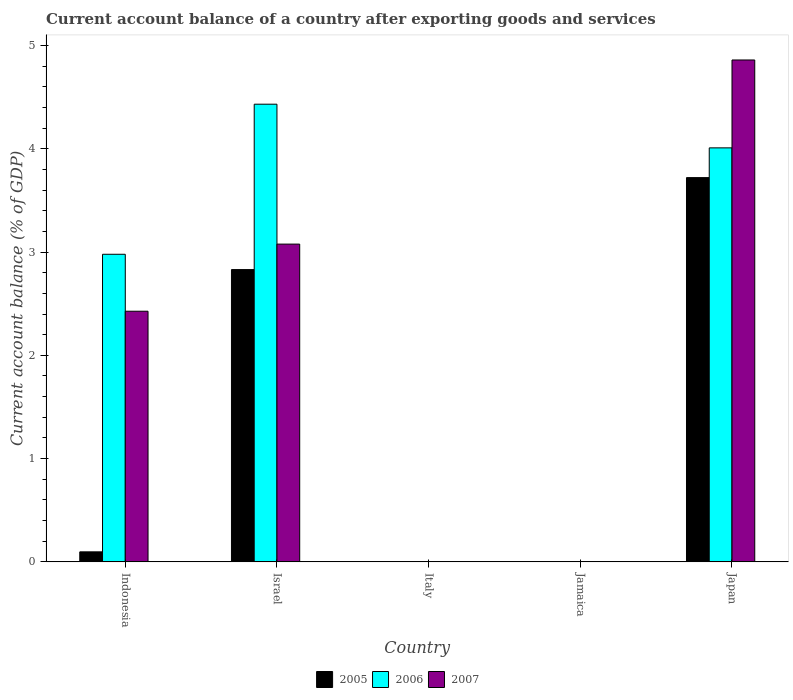How many different coloured bars are there?
Your answer should be very brief. 3. How many bars are there on the 3rd tick from the left?
Offer a terse response. 0. How many bars are there on the 4th tick from the right?
Your answer should be very brief. 3. What is the label of the 4th group of bars from the left?
Offer a very short reply. Jamaica. Across all countries, what is the maximum account balance in 2007?
Your response must be concise. 4.86. Across all countries, what is the minimum account balance in 2005?
Provide a succinct answer. 0. What is the total account balance in 2007 in the graph?
Offer a very short reply. 10.36. What is the difference between the account balance in 2006 in Indonesia and that in Israel?
Your answer should be very brief. -1.45. What is the difference between the account balance in 2006 in Jamaica and the account balance in 2007 in Indonesia?
Give a very brief answer. -2.43. What is the average account balance in 2007 per country?
Offer a terse response. 2.07. What is the difference between the account balance of/in 2005 and account balance of/in 2006 in Indonesia?
Your response must be concise. -2.88. In how many countries, is the account balance in 2006 greater than 4.6 %?
Provide a short and direct response. 0. Is the account balance in 2006 in Israel less than that in Japan?
Make the answer very short. No. What is the difference between the highest and the second highest account balance in 2005?
Give a very brief answer. -2.73. What is the difference between the highest and the lowest account balance in 2005?
Offer a very short reply. 3.72. In how many countries, is the account balance in 2007 greater than the average account balance in 2007 taken over all countries?
Provide a succinct answer. 3. Is the sum of the account balance in 2005 in Israel and Japan greater than the maximum account balance in 2006 across all countries?
Provide a succinct answer. Yes. How many bars are there?
Offer a very short reply. 9. Are all the bars in the graph horizontal?
Your response must be concise. No. How many countries are there in the graph?
Your response must be concise. 5. Are the values on the major ticks of Y-axis written in scientific E-notation?
Offer a terse response. No. Does the graph contain any zero values?
Your answer should be compact. Yes. Where does the legend appear in the graph?
Your answer should be very brief. Bottom center. How many legend labels are there?
Your answer should be very brief. 3. What is the title of the graph?
Make the answer very short. Current account balance of a country after exporting goods and services. What is the label or title of the Y-axis?
Offer a terse response. Current account balance (% of GDP). What is the Current account balance (% of GDP) in 2005 in Indonesia?
Provide a succinct answer. 0.1. What is the Current account balance (% of GDP) of 2006 in Indonesia?
Provide a succinct answer. 2.98. What is the Current account balance (% of GDP) in 2007 in Indonesia?
Offer a terse response. 2.43. What is the Current account balance (% of GDP) of 2005 in Israel?
Provide a succinct answer. 2.83. What is the Current account balance (% of GDP) in 2006 in Israel?
Your response must be concise. 4.43. What is the Current account balance (% of GDP) in 2007 in Israel?
Provide a short and direct response. 3.08. What is the Current account balance (% of GDP) of 2007 in Italy?
Your answer should be very brief. 0. What is the Current account balance (% of GDP) in 2005 in Jamaica?
Make the answer very short. 0. What is the Current account balance (% of GDP) of 2006 in Jamaica?
Provide a succinct answer. 0. What is the Current account balance (% of GDP) in 2005 in Japan?
Make the answer very short. 3.72. What is the Current account balance (% of GDP) in 2006 in Japan?
Provide a succinct answer. 4.01. What is the Current account balance (% of GDP) of 2007 in Japan?
Keep it short and to the point. 4.86. Across all countries, what is the maximum Current account balance (% of GDP) of 2005?
Offer a terse response. 3.72. Across all countries, what is the maximum Current account balance (% of GDP) in 2006?
Your answer should be very brief. 4.43. Across all countries, what is the maximum Current account balance (% of GDP) of 2007?
Your answer should be very brief. 4.86. Across all countries, what is the minimum Current account balance (% of GDP) of 2005?
Your answer should be very brief. 0. Across all countries, what is the minimum Current account balance (% of GDP) in 2006?
Ensure brevity in your answer.  0. Across all countries, what is the minimum Current account balance (% of GDP) in 2007?
Give a very brief answer. 0. What is the total Current account balance (% of GDP) of 2005 in the graph?
Provide a succinct answer. 6.65. What is the total Current account balance (% of GDP) of 2006 in the graph?
Your answer should be very brief. 11.42. What is the total Current account balance (% of GDP) of 2007 in the graph?
Your answer should be very brief. 10.36. What is the difference between the Current account balance (% of GDP) in 2005 in Indonesia and that in Israel?
Offer a very short reply. -2.73. What is the difference between the Current account balance (% of GDP) of 2006 in Indonesia and that in Israel?
Your answer should be very brief. -1.45. What is the difference between the Current account balance (% of GDP) of 2007 in Indonesia and that in Israel?
Make the answer very short. -0.65. What is the difference between the Current account balance (% of GDP) in 2005 in Indonesia and that in Japan?
Your response must be concise. -3.62. What is the difference between the Current account balance (% of GDP) of 2006 in Indonesia and that in Japan?
Ensure brevity in your answer.  -1.03. What is the difference between the Current account balance (% of GDP) of 2007 in Indonesia and that in Japan?
Provide a short and direct response. -2.43. What is the difference between the Current account balance (% of GDP) of 2005 in Israel and that in Japan?
Make the answer very short. -0.89. What is the difference between the Current account balance (% of GDP) in 2006 in Israel and that in Japan?
Ensure brevity in your answer.  0.42. What is the difference between the Current account balance (% of GDP) of 2007 in Israel and that in Japan?
Make the answer very short. -1.78. What is the difference between the Current account balance (% of GDP) of 2005 in Indonesia and the Current account balance (% of GDP) of 2006 in Israel?
Your answer should be very brief. -4.34. What is the difference between the Current account balance (% of GDP) of 2005 in Indonesia and the Current account balance (% of GDP) of 2007 in Israel?
Your answer should be very brief. -2.98. What is the difference between the Current account balance (% of GDP) in 2006 in Indonesia and the Current account balance (% of GDP) in 2007 in Israel?
Provide a short and direct response. -0.1. What is the difference between the Current account balance (% of GDP) of 2005 in Indonesia and the Current account balance (% of GDP) of 2006 in Japan?
Make the answer very short. -3.91. What is the difference between the Current account balance (% of GDP) of 2005 in Indonesia and the Current account balance (% of GDP) of 2007 in Japan?
Provide a succinct answer. -4.76. What is the difference between the Current account balance (% of GDP) of 2006 in Indonesia and the Current account balance (% of GDP) of 2007 in Japan?
Your answer should be very brief. -1.88. What is the difference between the Current account balance (% of GDP) in 2005 in Israel and the Current account balance (% of GDP) in 2006 in Japan?
Keep it short and to the point. -1.18. What is the difference between the Current account balance (% of GDP) in 2005 in Israel and the Current account balance (% of GDP) in 2007 in Japan?
Give a very brief answer. -2.03. What is the difference between the Current account balance (% of GDP) of 2006 in Israel and the Current account balance (% of GDP) of 2007 in Japan?
Your answer should be compact. -0.43. What is the average Current account balance (% of GDP) in 2005 per country?
Provide a short and direct response. 1.33. What is the average Current account balance (% of GDP) of 2006 per country?
Your answer should be very brief. 2.28. What is the average Current account balance (% of GDP) in 2007 per country?
Make the answer very short. 2.07. What is the difference between the Current account balance (% of GDP) of 2005 and Current account balance (% of GDP) of 2006 in Indonesia?
Ensure brevity in your answer.  -2.88. What is the difference between the Current account balance (% of GDP) in 2005 and Current account balance (% of GDP) in 2007 in Indonesia?
Make the answer very short. -2.33. What is the difference between the Current account balance (% of GDP) in 2006 and Current account balance (% of GDP) in 2007 in Indonesia?
Offer a very short reply. 0.55. What is the difference between the Current account balance (% of GDP) of 2005 and Current account balance (% of GDP) of 2006 in Israel?
Your answer should be compact. -1.6. What is the difference between the Current account balance (% of GDP) of 2005 and Current account balance (% of GDP) of 2007 in Israel?
Offer a very short reply. -0.25. What is the difference between the Current account balance (% of GDP) in 2006 and Current account balance (% of GDP) in 2007 in Israel?
Your answer should be compact. 1.35. What is the difference between the Current account balance (% of GDP) of 2005 and Current account balance (% of GDP) of 2006 in Japan?
Keep it short and to the point. -0.29. What is the difference between the Current account balance (% of GDP) of 2005 and Current account balance (% of GDP) of 2007 in Japan?
Ensure brevity in your answer.  -1.14. What is the difference between the Current account balance (% of GDP) in 2006 and Current account balance (% of GDP) in 2007 in Japan?
Your response must be concise. -0.85. What is the ratio of the Current account balance (% of GDP) in 2005 in Indonesia to that in Israel?
Your answer should be very brief. 0.03. What is the ratio of the Current account balance (% of GDP) of 2006 in Indonesia to that in Israel?
Provide a short and direct response. 0.67. What is the ratio of the Current account balance (% of GDP) in 2007 in Indonesia to that in Israel?
Your answer should be compact. 0.79. What is the ratio of the Current account balance (% of GDP) in 2005 in Indonesia to that in Japan?
Your response must be concise. 0.03. What is the ratio of the Current account balance (% of GDP) of 2006 in Indonesia to that in Japan?
Provide a short and direct response. 0.74. What is the ratio of the Current account balance (% of GDP) of 2007 in Indonesia to that in Japan?
Make the answer very short. 0.5. What is the ratio of the Current account balance (% of GDP) in 2005 in Israel to that in Japan?
Provide a succinct answer. 0.76. What is the ratio of the Current account balance (% of GDP) in 2006 in Israel to that in Japan?
Give a very brief answer. 1.11. What is the ratio of the Current account balance (% of GDP) of 2007 in Israel to that in Japan?
Your answer should be compact. 0.63. What is the difference between the highest and the second highest Current account balance (% of GDP) in 2005?
Keep it short and to the point. 0.89. What is the difference between the highest and the second highest Current account balance (% of GDP) of 2006?
Offer a terse response. 0.42. What is the difference between the highest and the second highest Current account balance (% of GDP) of 2007?
Ensure brevity in your answer.  1.78. What is the difference between the highest and the lowest Current account balance (% of GDP) of 2005?
Your response must be concise. 3.72. What is the difference between the highest and the lowest Current account balance (% of GDP) of 2006?
Your answer should be compact. 4.43. What is the difference between the highest and the lowest Current account balance (% of GDP) of 2007?
Provide a succinct answer. 4.86. 